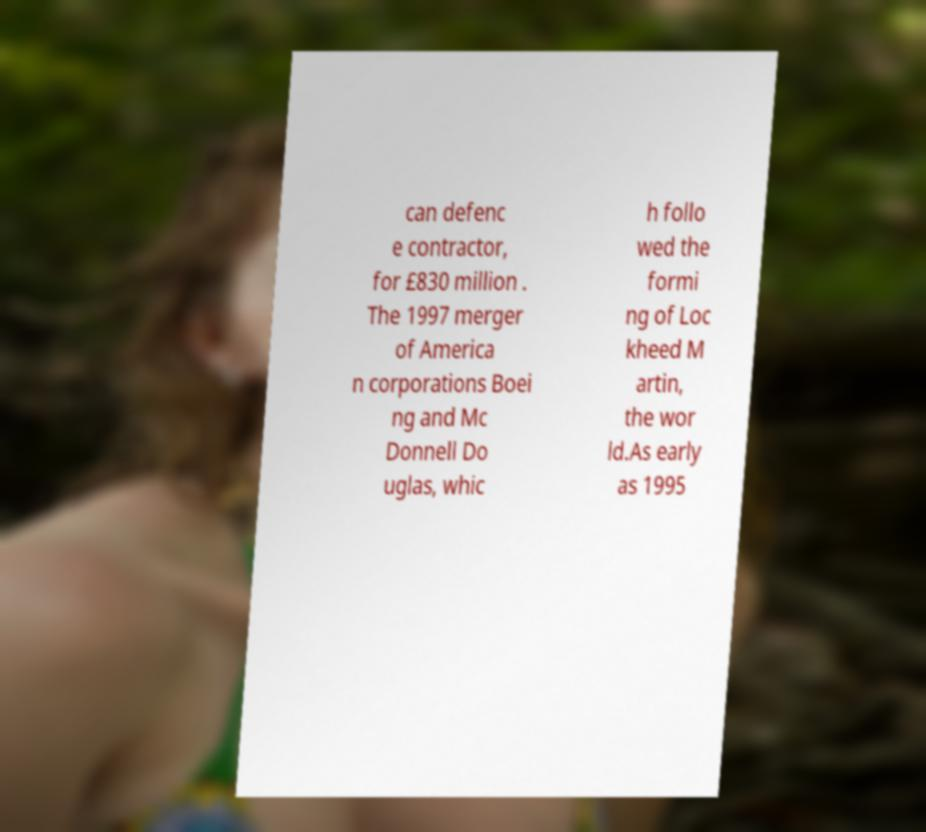There's text embedded in this image that I need extracted. Can you transcribe it verbatim? can defenc e contractor, for £830 million . The 1997 merger of America n corporations Boei ng and Mc Donnell Do uglas, whic h follo wed the formi ng of Loc kheed M artin, the wor ld.As early as 1995 